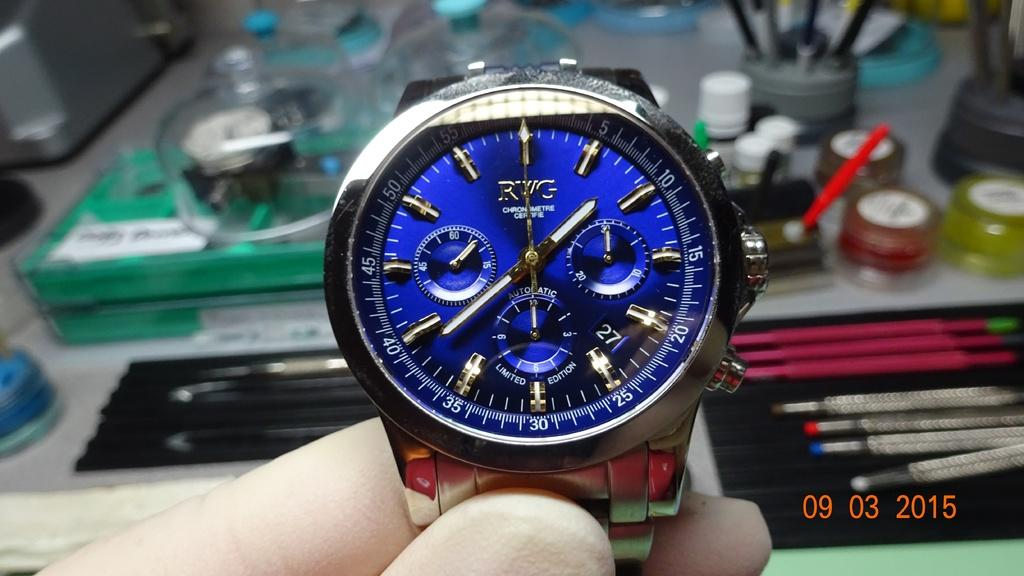<image>
Describe the image concisely. A blue watch gives the time of 1:39. 